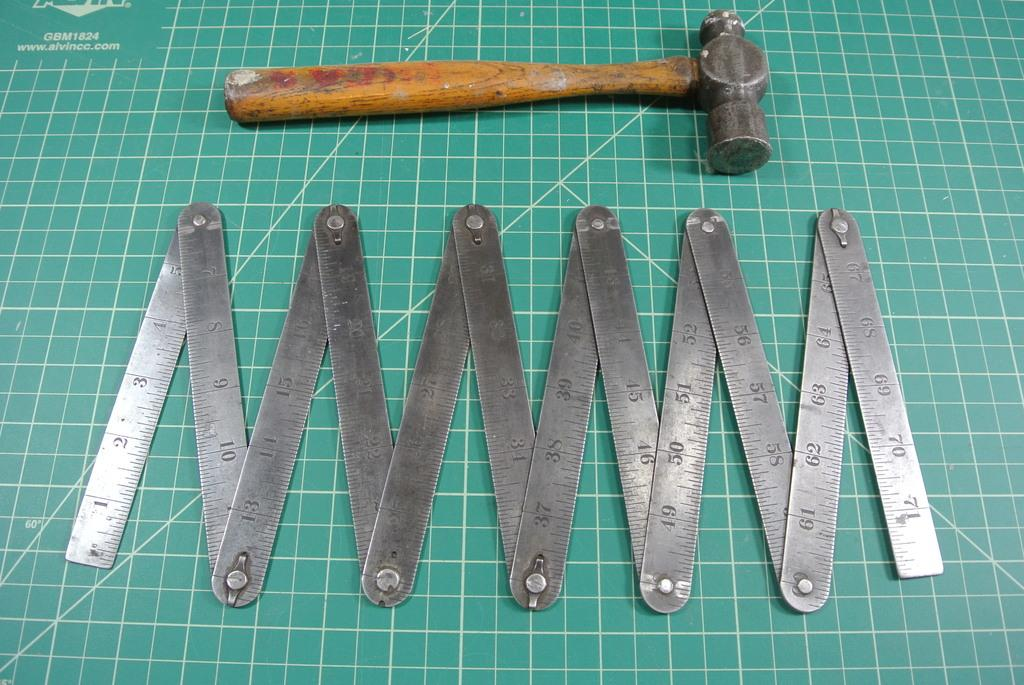<image>
Describe the image concisely. Tools are laid out on a green mat, which is labelled GBM1824 and has the website ww.alvincc.com printed on it. 